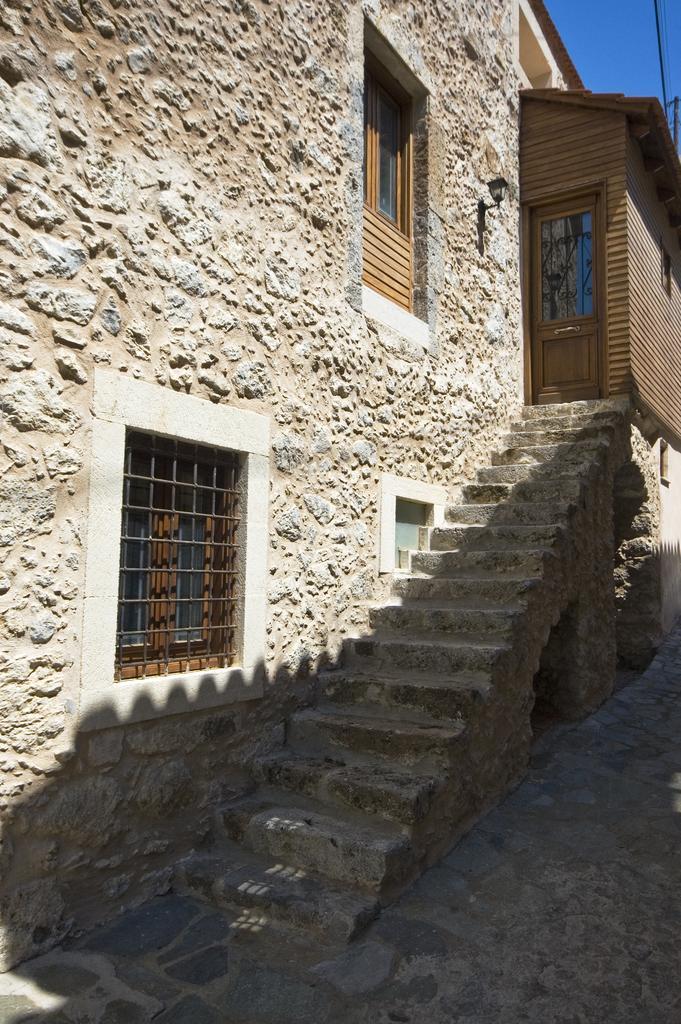In one or two sentences, can you explain what this image depicts? This picture shows buildings and we see stairs to climb and couple of Windows to the Wall and a light fixed to the wall and a blue sky 